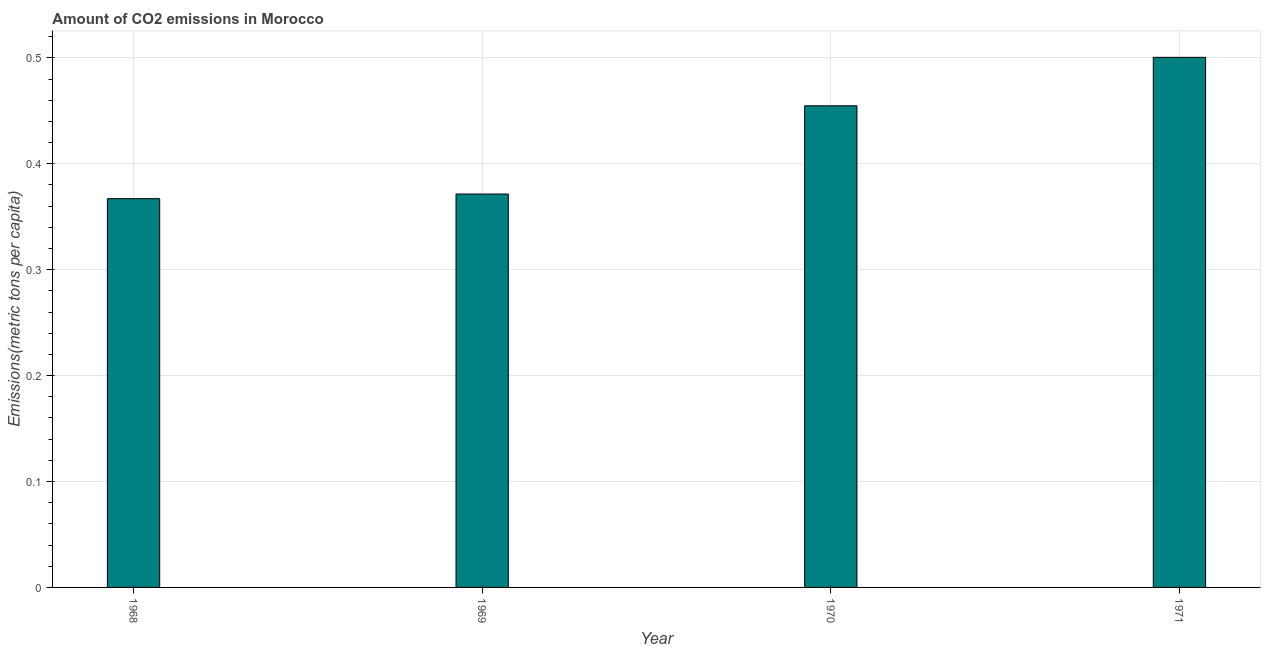Does the graph contain grids?
Give a very brief answer. Yes. What is the title of the graph?
Ensure brevity in your answer.  Amount of CO2 emissions in Morocco. What is the label or title of the Y-axis?
Make the answer very short. Emissions(metric tons per capita). What is the amount of co2 emissions in 1971?
Make the answer very short. 0.5. Across all years, what is the maximum amount of co2 emissions?
Keep it short and to the point. 0.5. Across all years, what is the minimum amount of co2 emissions?
Make the answer very short. 0.37. In which year was the amount of co2 emissions maximum?
Offer a very short reply. 1971. In which year was the amount of co2 emissions minimum?
Keep it short and to the point. 1968. What is the sum of the amount of co2 emissions?
Give a very brief answer. 1.69. What is the difference between the amount of co2 emissions in 1968 and 1970?
Make the answer very short. -0.09. What is the average amount of co2 emissions per year?
Make the answer very short. 0.42. What is the median amount of co2 emissions?
Your answer should be compact. 0.41. What is the ratio of the amount of co2 emissions in 1968 to that in 1971?
Ensure brevity in your answer.  0.73. Is the amount of co2 emissions in 1968 less than that in 1971?
Provide a succinct answer. Yes. Is the difference between the amount of co2 emissions in 1969 and 1971 greater than the difference between any two years?
Give a very brief answer. No. What is the difference between the highest and the second highest amount of co2 emissions?
Ensure brevity in your answer.  0.05. Is the sum of the amount of co2 emissions in 1968 and 1969 greater than the maximum amount of co2 emissions across all years?
Offer a very short reply. Yes. What is the difference between the highest and the lowest amount of co2 emissions?
Ensure brevity in your answer.  0.13. How many bars are there?
Offer a very short reply. 4. Are all the bars in the graph horizontal?
Your answer should be very brief. No. What is the difference between two consecutive major ticks on the Y-axis?
Keep it short and to the point. 0.1. Are the values on the major ticks of Y-axis written in scientific E-notation?
Provide a succinct answer. No. What is the Emissions(metric tons per capita) in 1968?
Your answer should be very brief. 0.37. What is the Emissions(metric tons per capita) of 1969?
Your answer should be compact. 0.37. What is the Emissions(metric tons per capita) in 1970?
Your answer should be very brief. 0.45. What is the Emissions(metric tons per capita) in 1971?
Your answer should be very brief. 0.5. What is the difference between the Emissions(metric tons per capita) in 1968 and 1969?
Offer a terse response. -0. What is the difference between the Emissions(metric tons per capita) in 1968 and 1970?
Make the answer very short. -0.09. What is the difference between the Emissions(metric tons per capita) in 1968 and 1971?
Your answer should be very brief. -0.13. What is the difference between the Emissions(metric tons per capita) in 1969 and 1970?
Keep it short and to the point. -0.08. What is the difference between the Emissions(metric tons per capita) in 1969 and 1971?
Offer a terse response. -0.13. What is the difference between the Emissions(metric tons per capita) in 1970 and 1971?
Provide a succinct answer. -0.05. What is the ratio of the Emissions(metric tons per capita) in 1968 to that in 1970?
Offer a very short reply. 0.81. What is the ratio of the Emissions(metric tons per capita) in 1968 to that in 1971?
Provide a succinct answer. 0.73. What is the ratio of the Emissions(metric tons per capita) in 1969 to that in 1970?
Your answer should be compact. 0.82. What is the ratio of the Emissions(metric tons per capita) in 1969 to that in 1971?
Provide a short and direct response. 0.74. What is the ratio of the Emissions(metric tons per capita) in 1970 to that in 1971?
Your answer should be very brief. 0.91. 